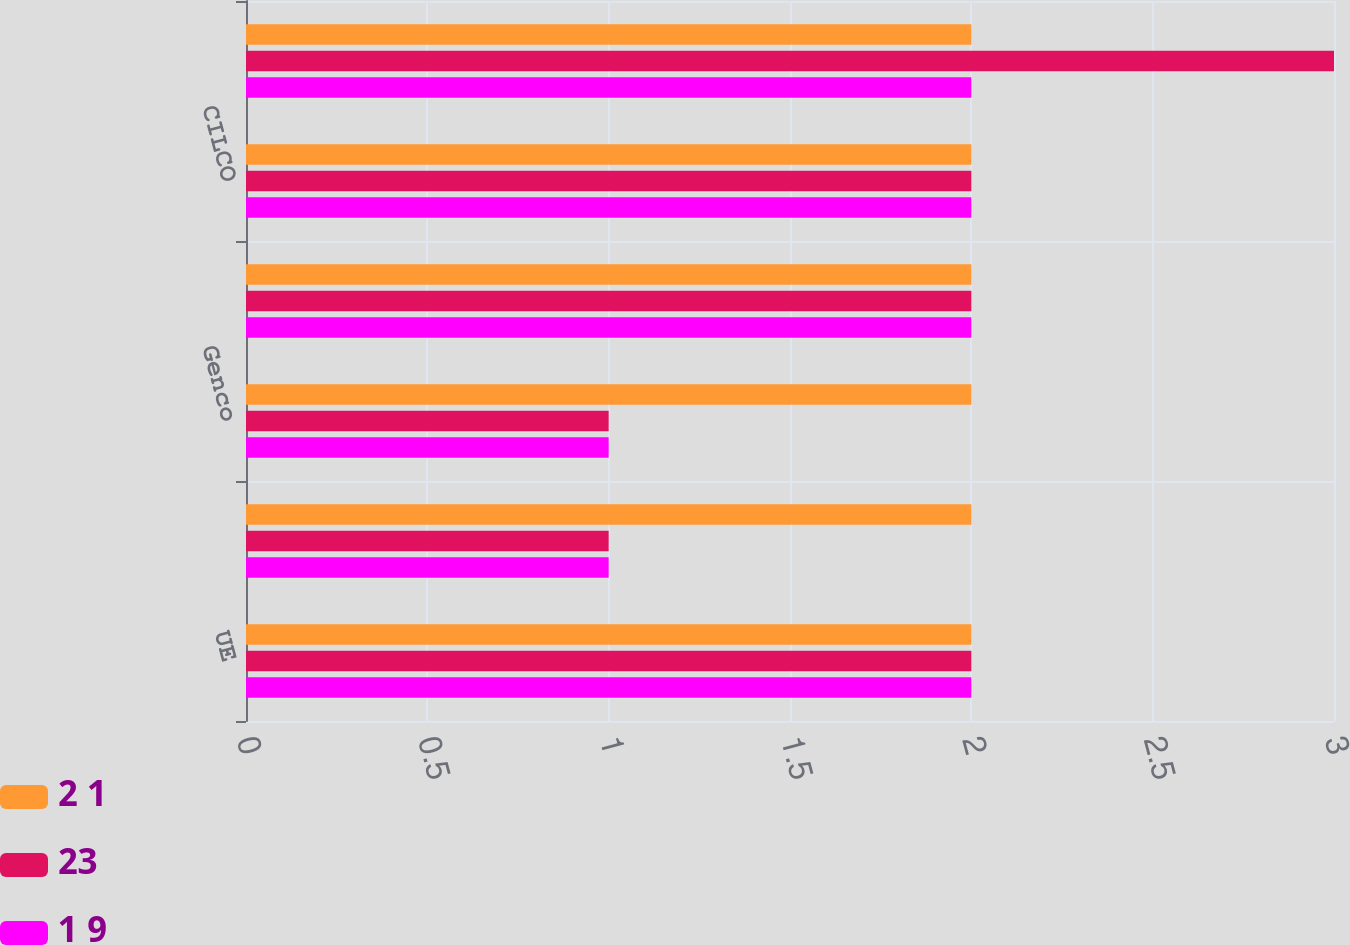Convert chart to OTSL. <chart><loc_0><loc_0><loc_500><loc_500><stacked_bar_chart><ecel><fcel>UE<fcel>CIPS<fcel>Genco<fcel>CILCORP<fcel>CILCO<fcel>IP<nl><fcel>2 1<fcel>2<fcel>2<fcel>2<fcel>2<fcel>2<fcel>2<nl><fcel>23<fcel>2<fcel>1<fcel>1<fcel>2<fcel>2<fcel>3<nl><fcel>1 9<fcel>2<fcel>1<fcel>1<fcel>2<fcel>2<fcel>2<nl></chart> 